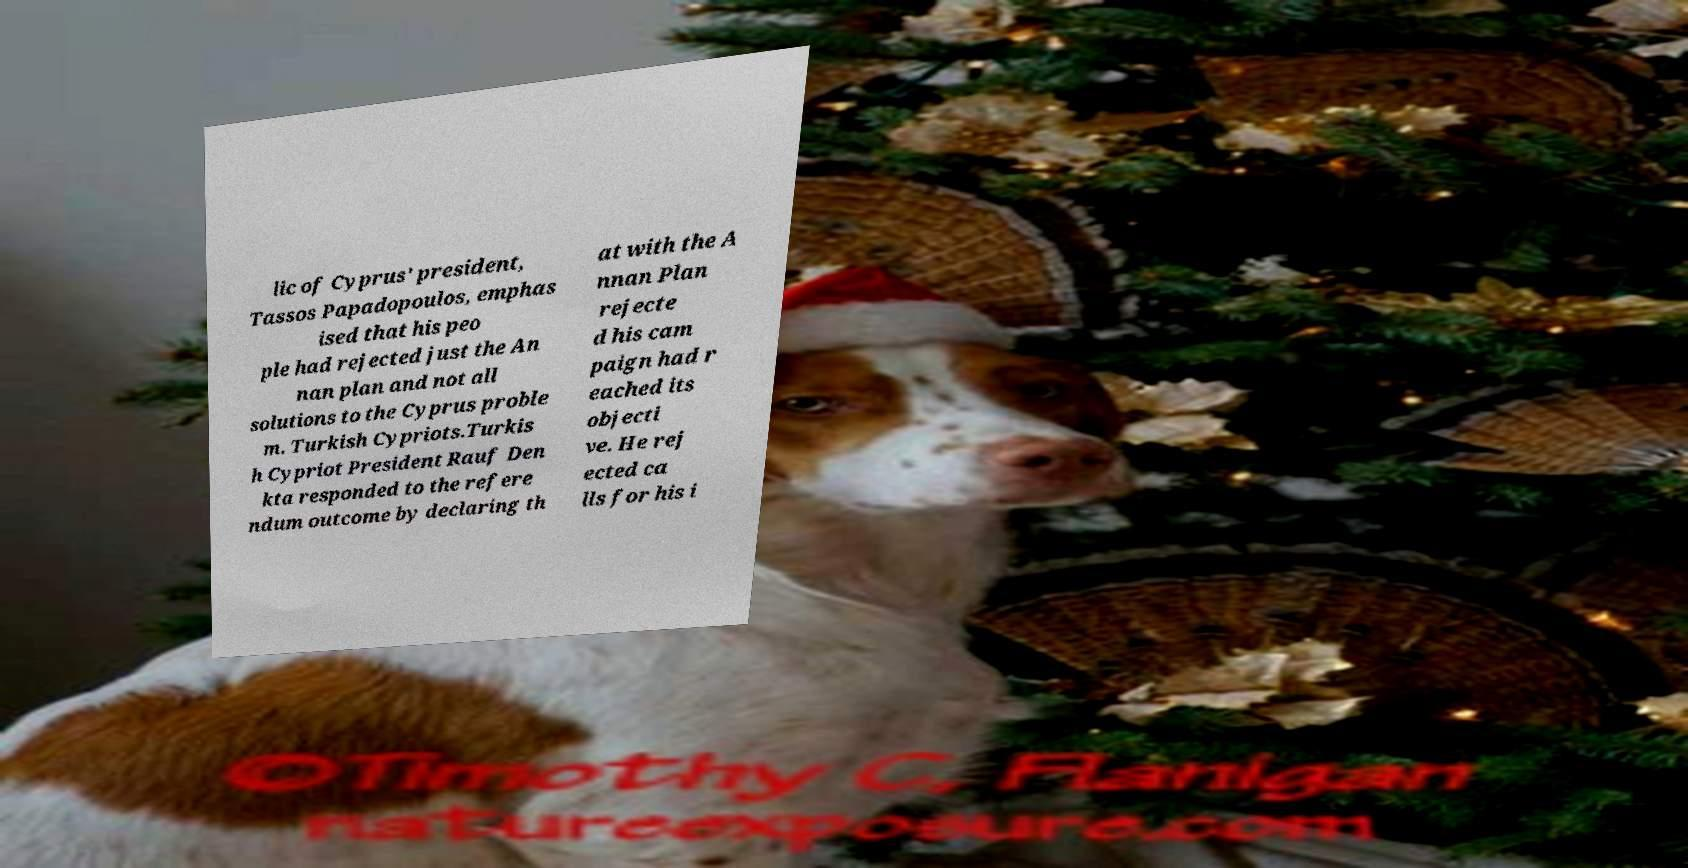I need the written content from this picture converted into text. Can you do that? lic of Cyprus' president, Tassos Papadopoulos, emphas ised that his peo ple had rejected just the An nan plan and not all solutions to the Cyprus proble m. Turkish Cypriots.Turkis h Cypriot President Rauf Den kta responded to the refere ndum outcome by declaring th at with the A nnan Plan rejecte d his cam paign had r eached its objecti ve. He rej ected ca lls for his i 